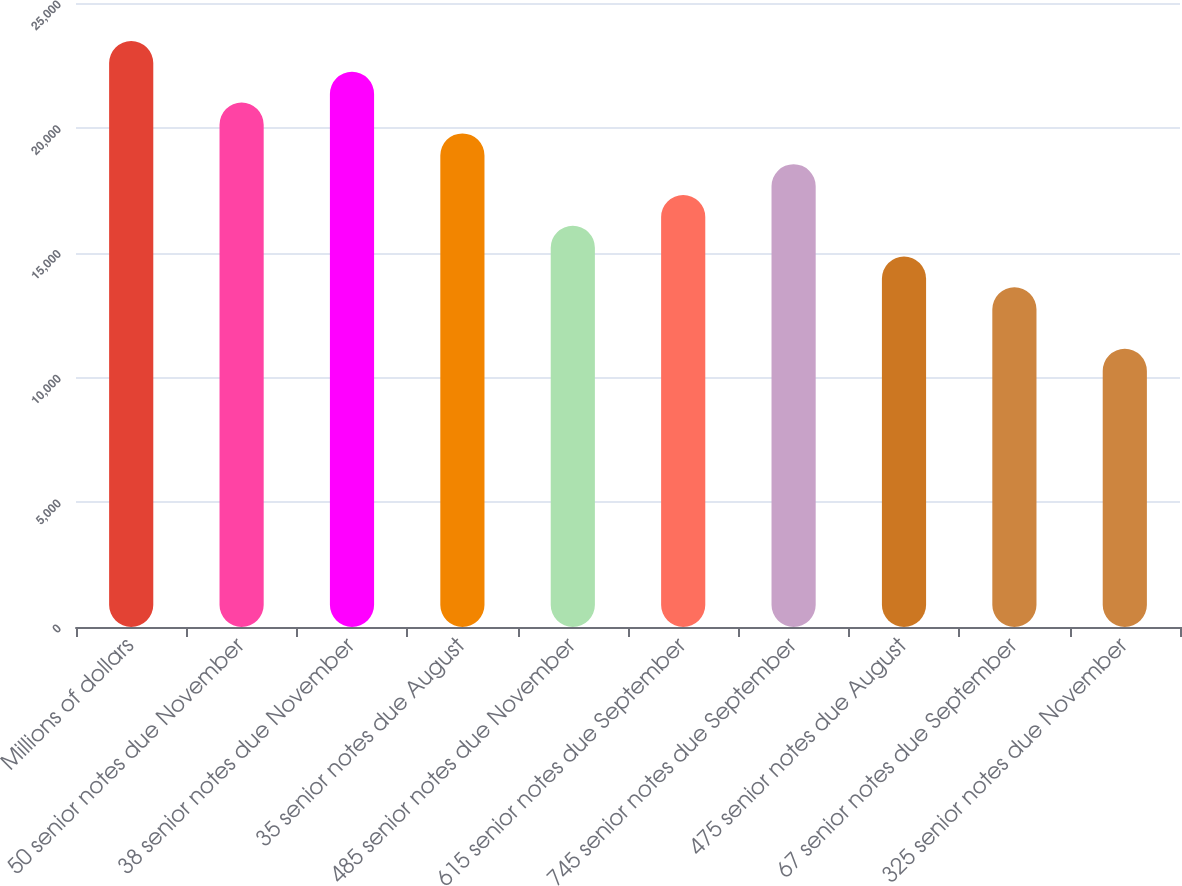Convert chart to OTSL. <chart><loc_0><loc_0><loc_500><loc_500><bar_chart><fcel>Millions of dollars<fcel>50 senior notes due November<fcel>38 senior notes due November<fcel>35 senior notes due August<fcel>485 senior notes due November<fcel>615 senior notes due September<fcel>745 senior notes due September<fcel>475 senior notes due August<fcel>67 senior notes due September<fcel>325 senior notes due November<nl><fcel>23475.8<fcel>21009.4<fcel>22242.6<fcel>19776.2<fcel>16076.6<fcel>17309.8<fcel>18543<fcel>14843.4<fcel>13610.2<fcel>11143.8<nl></chart> 